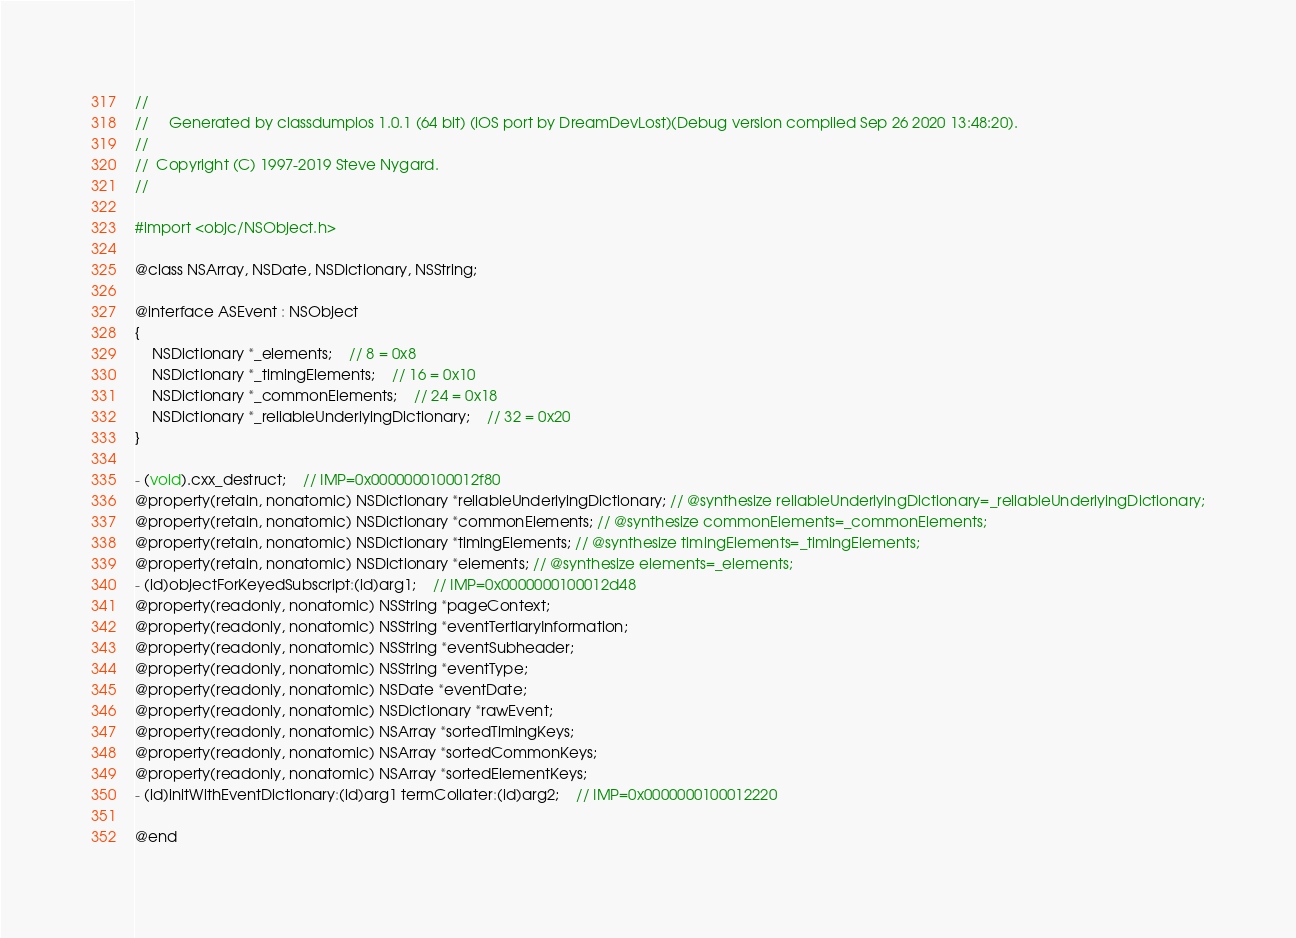Convert code to text. <code><loc_0><loc_0><loc_500><loc_500><_C_>//
//     Generated by classdumpios 1.0.1 (64 bit) (iOS port by DreamDevLost)(Debug version compiled Sep 26 2020 13:48:20).
//
//  Copyright (C) 1997-2019 Steve Nygard.
//

#import <objc/NSObject.h>

@class NSArray, NSDate, NSDictionary, NSString;

@interface ASEvent : NSObject
{
    NSDictionary *_elements;	// 8 = 0x8
    NSDictionary *_timingElements;	// 16 = 0x10
    NSDictionary *_commonElements;	// 24 = 0x18
    NSDictionary *_reliableUnderlyingDictionary;	// 32 = 0x20
}

- (void).cxx_destruct;	// IMP=0x0000000100012f80
@property(retain, nonatomic) NSDictionary *reliableUnderlyingDictionary; // @synthesize reliableUnderlyingDictionary=_reliableUnderlyingDictionary;
@property(retain, nonatomic) NSDictionary *commonElements; // @synthesize commonElements=_commonElements;
@property(retain, nonatomic) NSDictionary *timingElements; // @synthesize timingElements=_timingElements;
@property(retain, nonatomic) NSDictionary *elements; // @synthesize elements=_elements;
- (id)objectForKeyedSubscript:(id)arg1;	// IMP=0x0000000100012d48
@property(readonly, nonatomic) NSString *pageContext;
@property(readonly, nonatomic) NSString *eventTertiaryInformation;
@property(readonly, nonatomic) NSString *eventSubheader;
@property(readonly, nonatomic) NSString *eventType;
@property(readonly, nonatomic) NSDate *eventDate;
@property(readonly, nonatomic) NSDictionary *rawEvent;
@property(readonly, nonatomic) NSArray *sortedTimingKeys;
@property(readonly, nonatomic) NSArray *sortedCommonKeys;
@property(readonly, nonatomic) NSArray *sortedElementKeys;
- (id)initWithEventDictionary:(id)arg1 termCollater:(id)arg2;	// IMP=0x0000000100012220

@end

</code> 